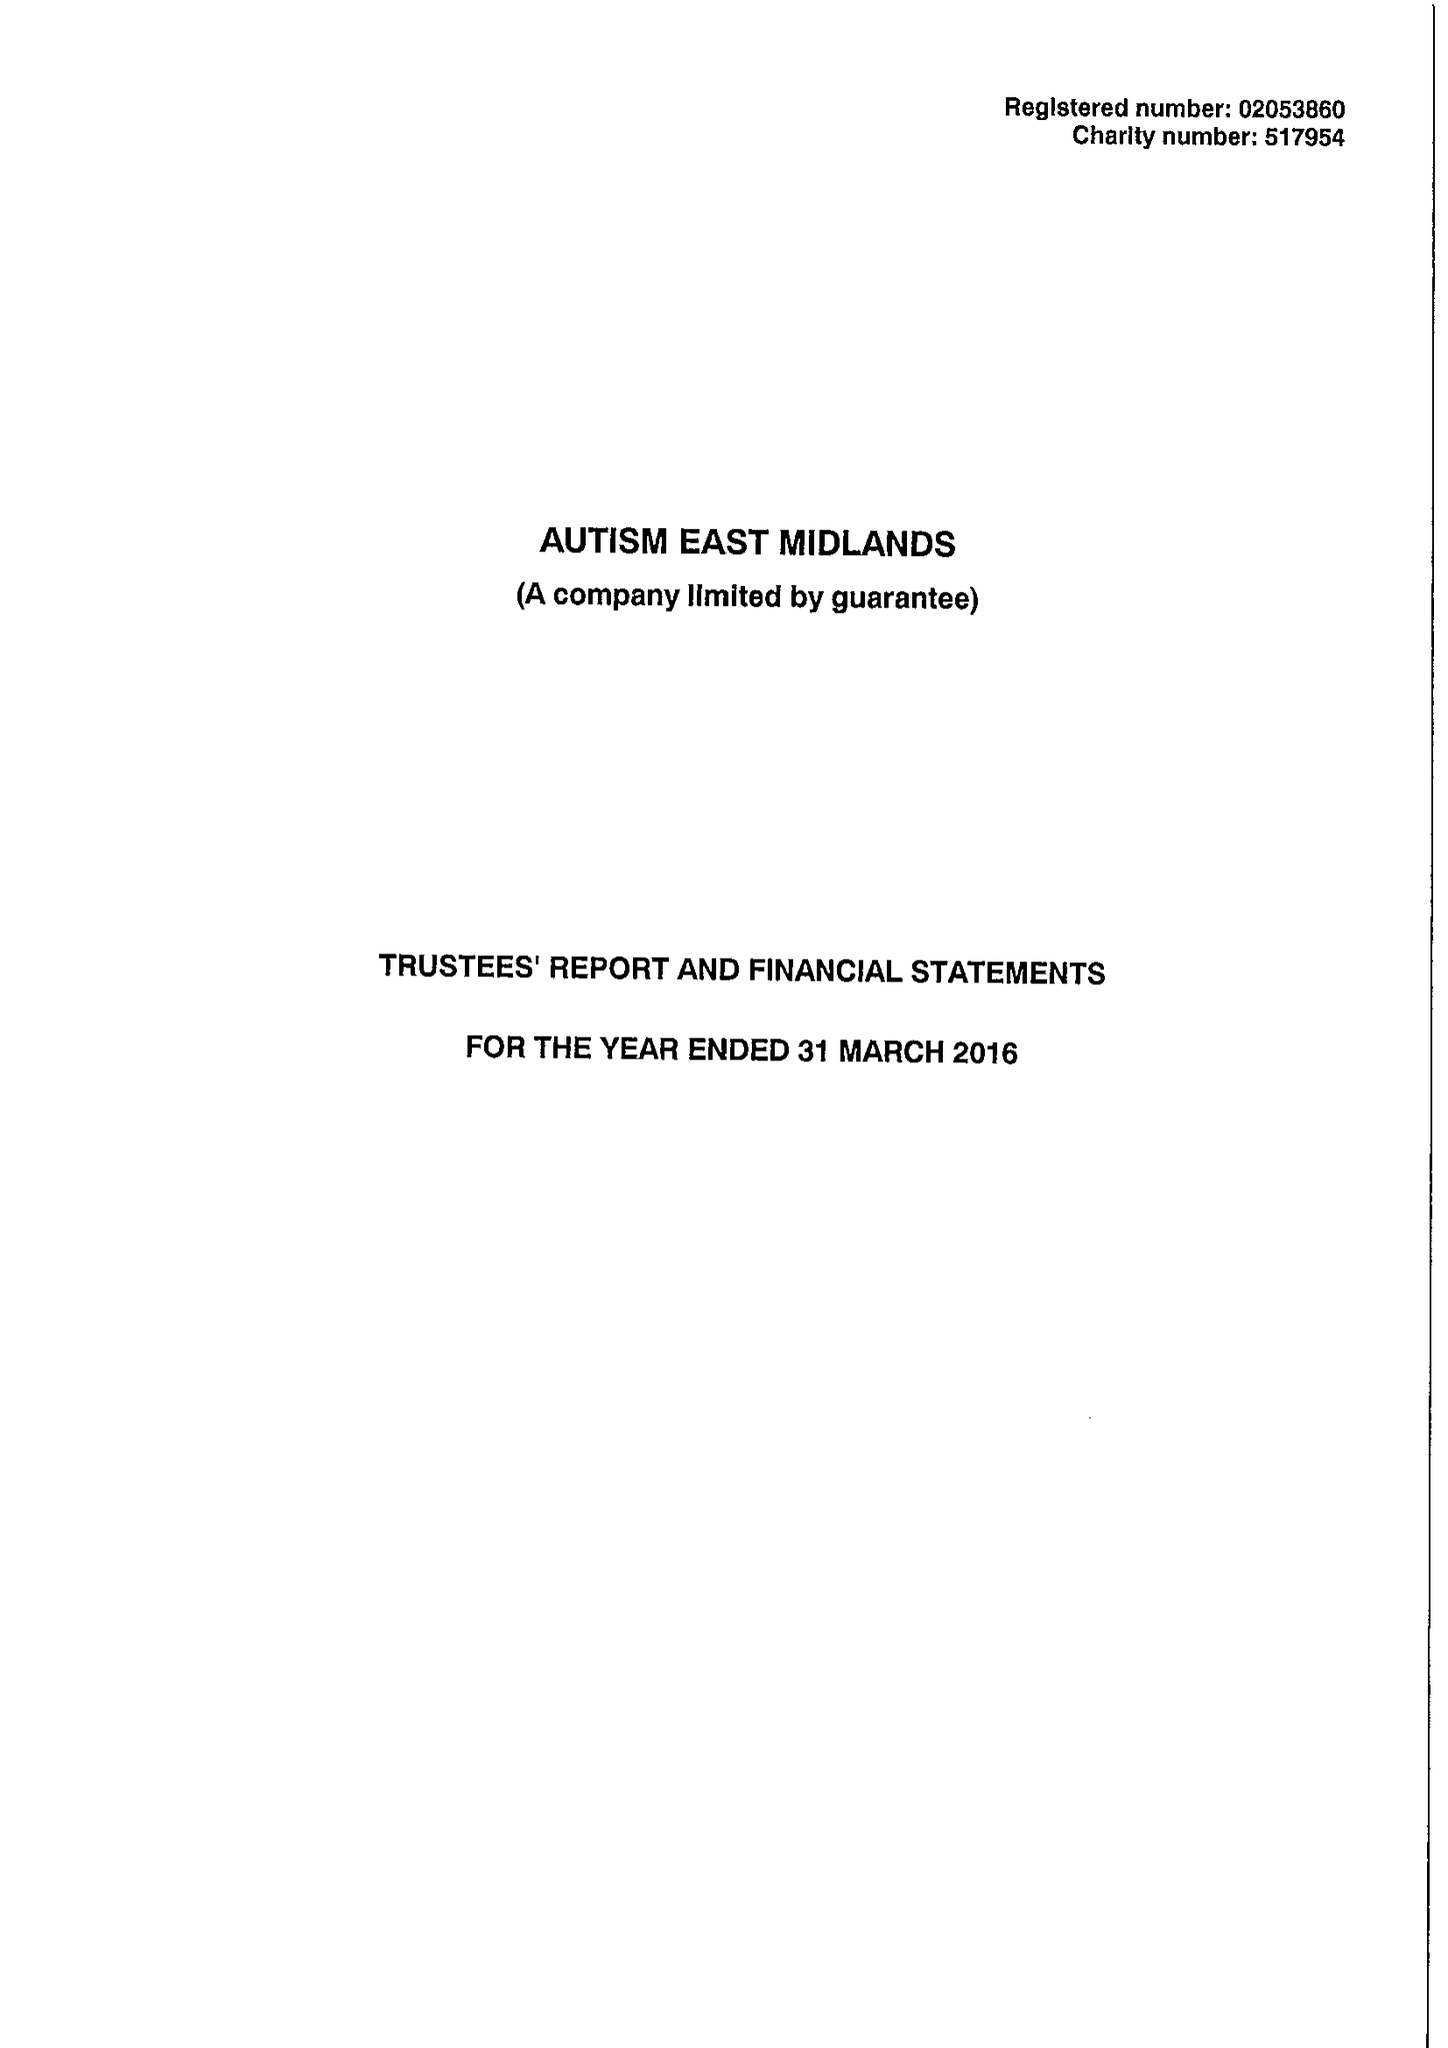What is the value for the income_annually_in_british_pounds?
Answer the question using a single word or phrase. 11976081.00 